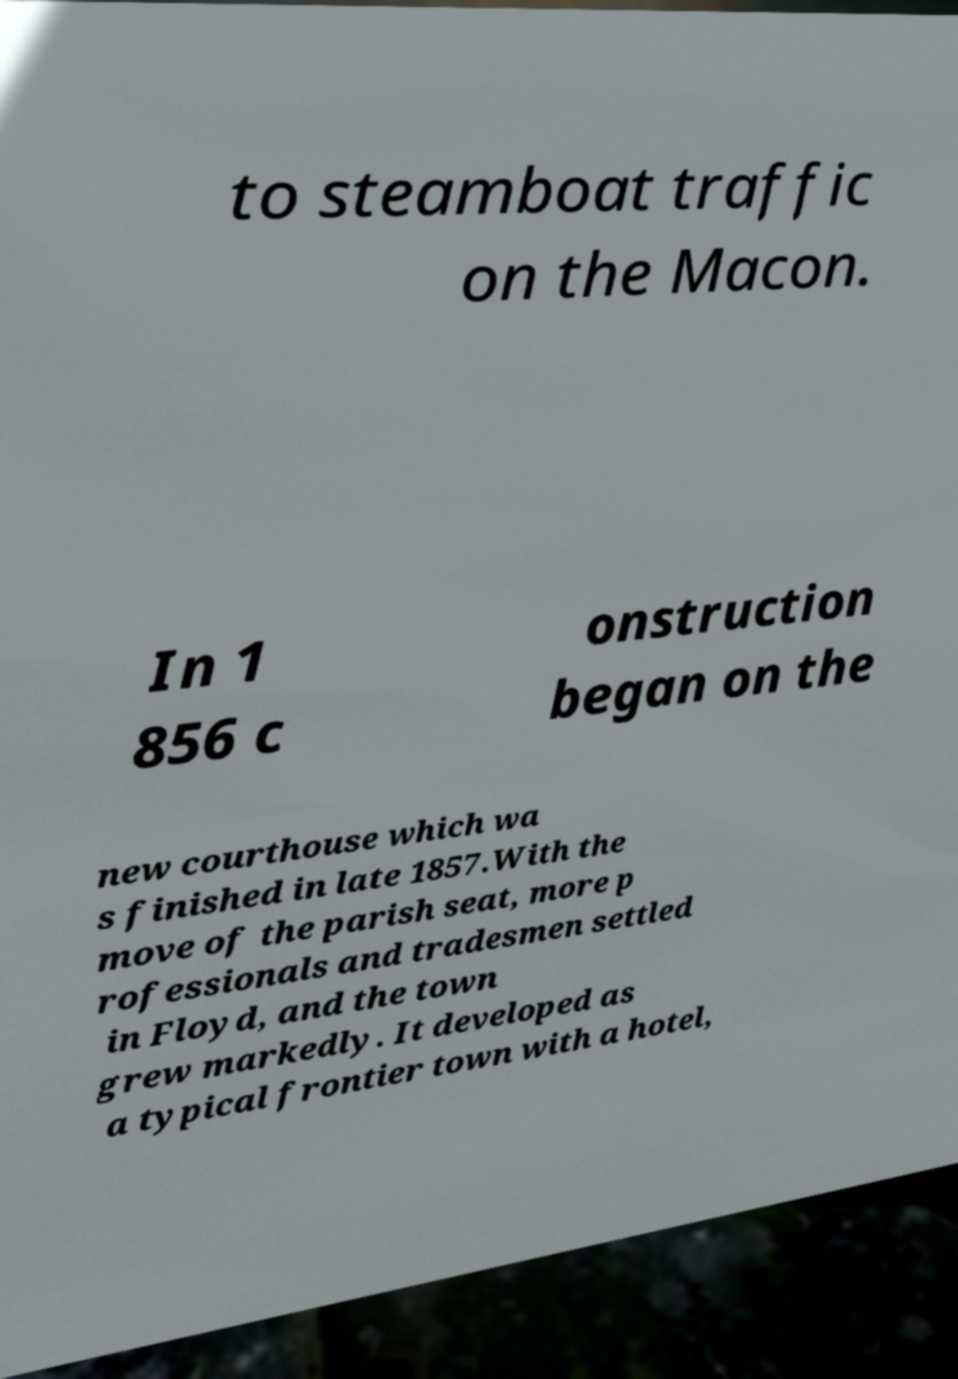What messages or text are displayed in this image? I need them in a readable, typed format. to steamboat traffic on the Macon. In 1 856 c onstruction began on the new courthouse which wa s finished in late 1857.With the move of the parish seat, more p rofessionals and tradesmen settled in Floyd, and the town grew markedly. It developed as a typical frontier town with a hotel, 